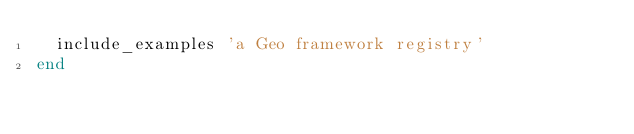<code> <loc_0><loc_0><loc_500><loc_500><_Ruby_>  include_examples 'a Geo framework registry'
end
</code> 